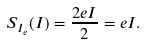Convert formula to latex. <formula><loc_0><loc_0><loc_500><loc_500>S _ { I _ { e } } ( I ) = \frac { 2 e I } { 2 } = e I .</formula> 